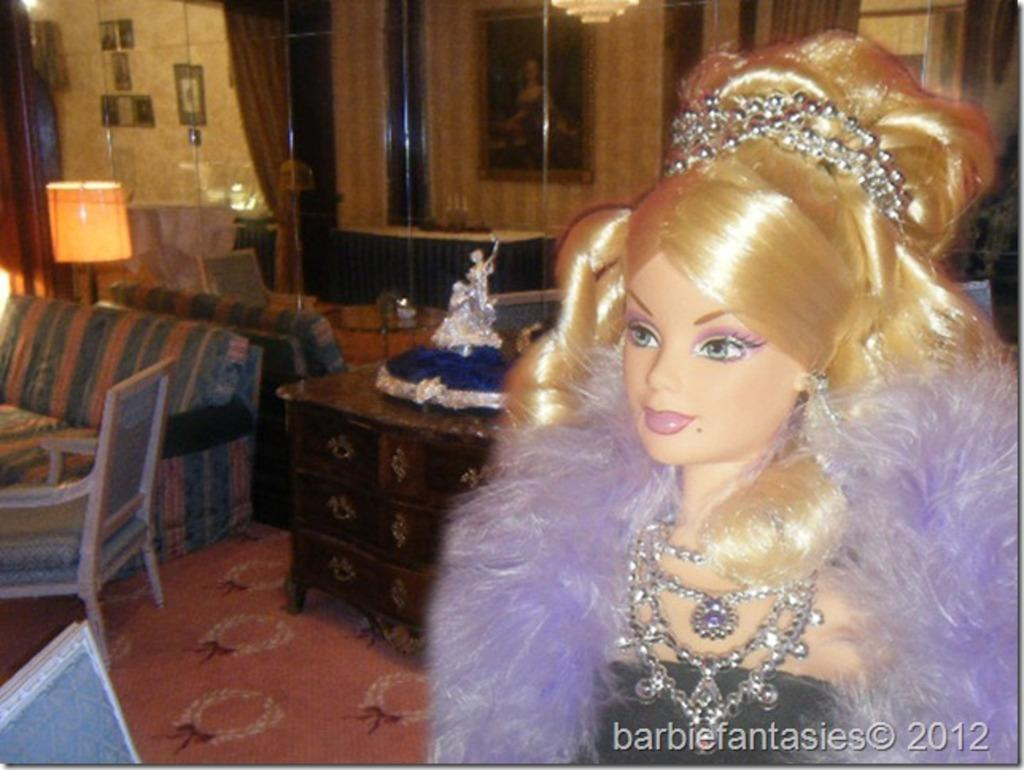What object can be seen in the image that is meant for play or entertainment? There is a toy in the image. What type of seating is visible in the background of the image? There is a light sofa and a chair in the background of the image. Can you see any visible veins in the toy in the image? There are no visible veins in the toy, as it is not a living organism. 